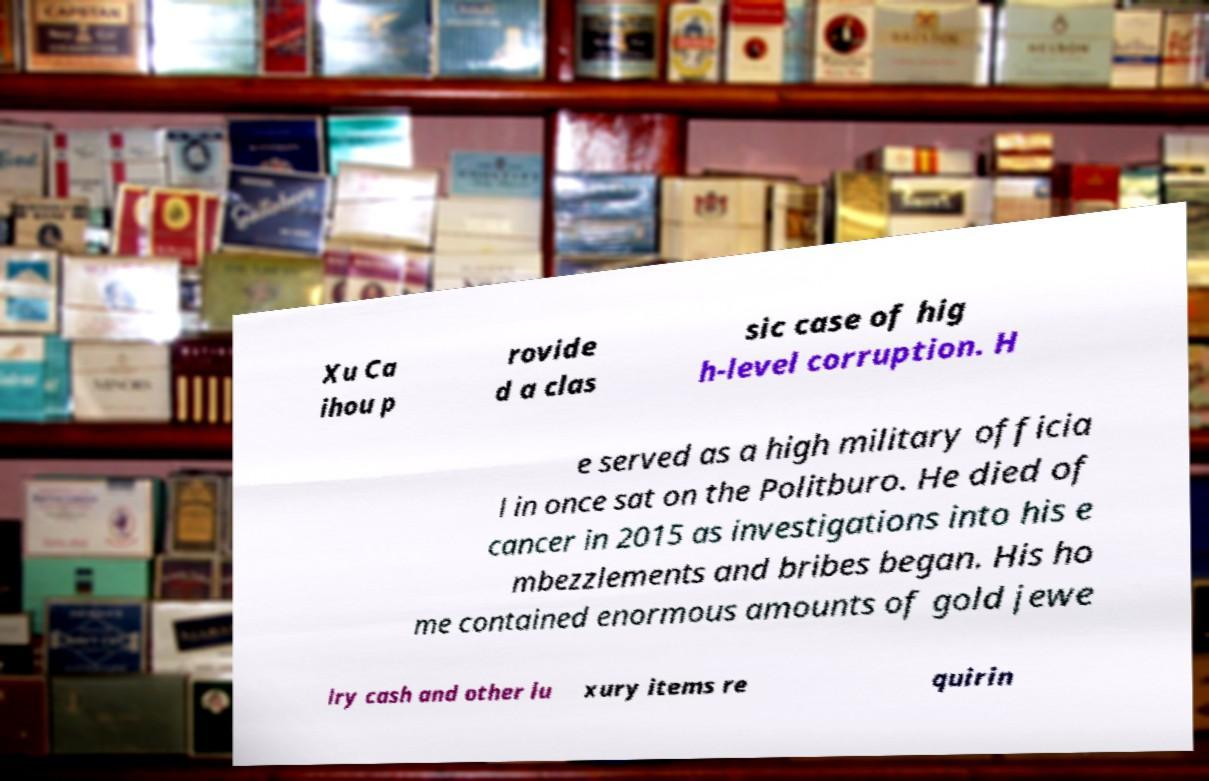For documentation purposes, I need the text within this image transcribed. Could you provide that? Xu Ca ihou p rovide d a clas sic case of hig h-level corruption. H e served as a high military officia l in once sat on the Politburo. He died of cancer in 2015 as investigations into his e mbezzlements and bribes began. His ho me contained enormous amounts of gold jewe lry cash and other lu xury items re quirin 